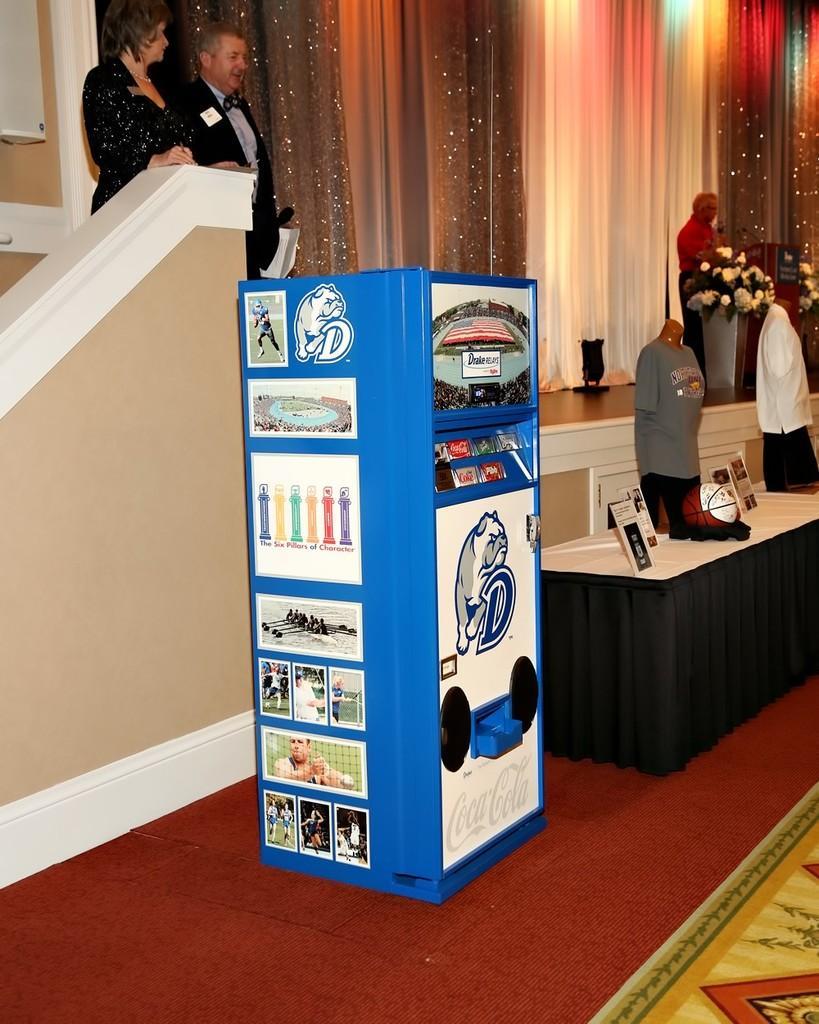Can you describe this image briefly? A place which has three people and the things like basketball, shirts and the coca cola desk on the left side of the picture and the flowers on the right side of the picture. 